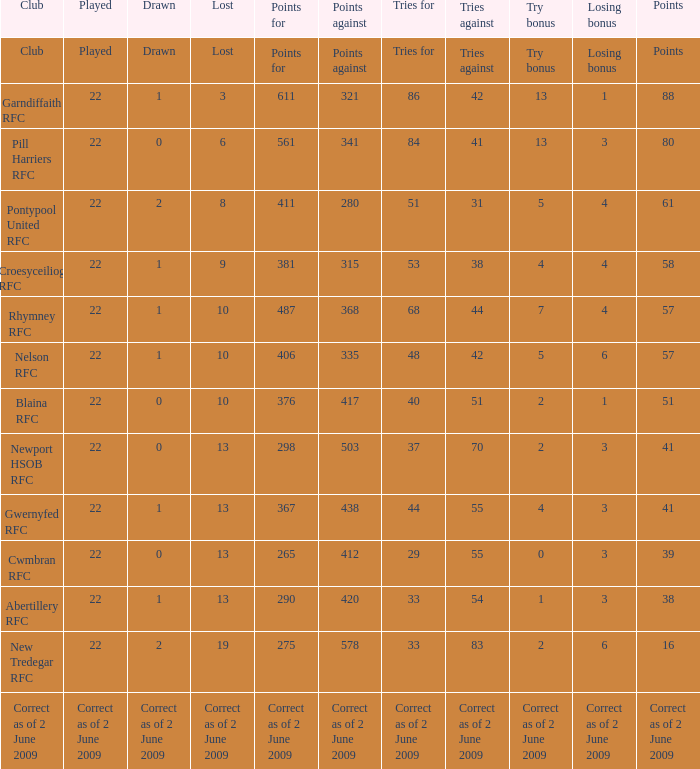How many tries against did the club with 1 drawn and 41 points have? 55.0. 